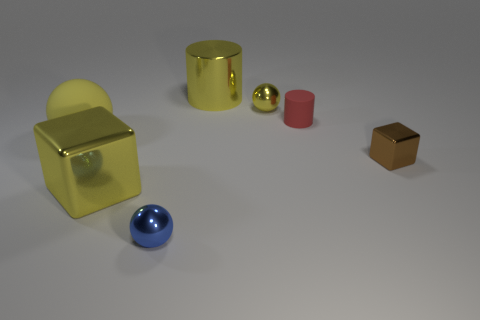Add 1 tiny red matte cylinders. How many objects exist? 8 Subtract all cylinders. How many objects are left? 5 Subtract all tiny metal balls. Subtract all small red cylinders. How many objects are left? 4 Add 7 small rubber things. How many small rubber things are left? 8 Add 5 yellow things. How many yellow things exist? 9 Subtract 0 blue cylinders. How many objects are left? 7 